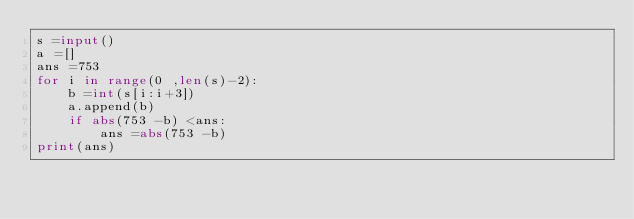<code> <loc_0><loc_0><loc_500><loc_500><_Python_>s =input()
a =[]
ans =753
for i in range(0 ,len(s)-2):
    b =int(s[i:i+3])
    a.append(b)
    if abs(753 -b) <ans:
        ans =abs(753 -b)
print(ans)</code> 